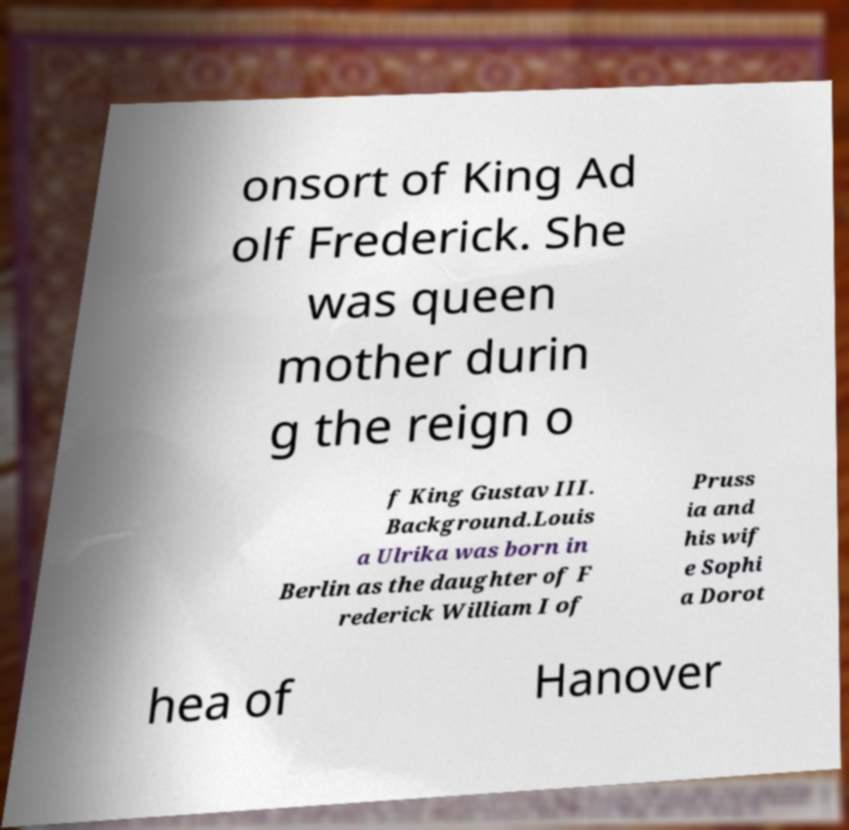Please read and relay the text visible in this image. What does it say? onsort of King Ad olf Frederick. She was queen mother durin g the reign o f King Gustav III. Background.Louis a Ulrika was born in Berlin as the daughter of F rederick William I of Pruss ia and his wif e Sophi a Dorot hea of Hanover 